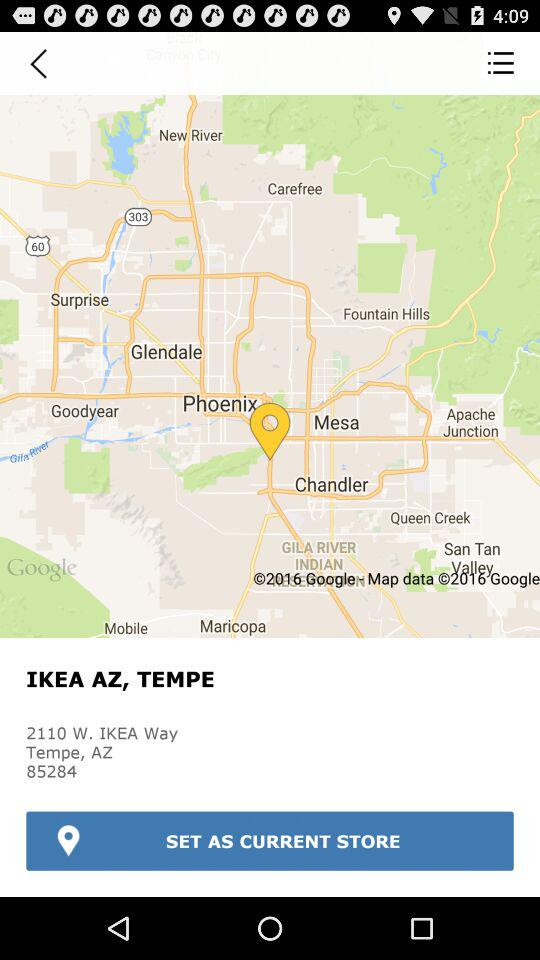What is the location? The location is 2110 W. IKEA Way Tempe, AZ 85284. 